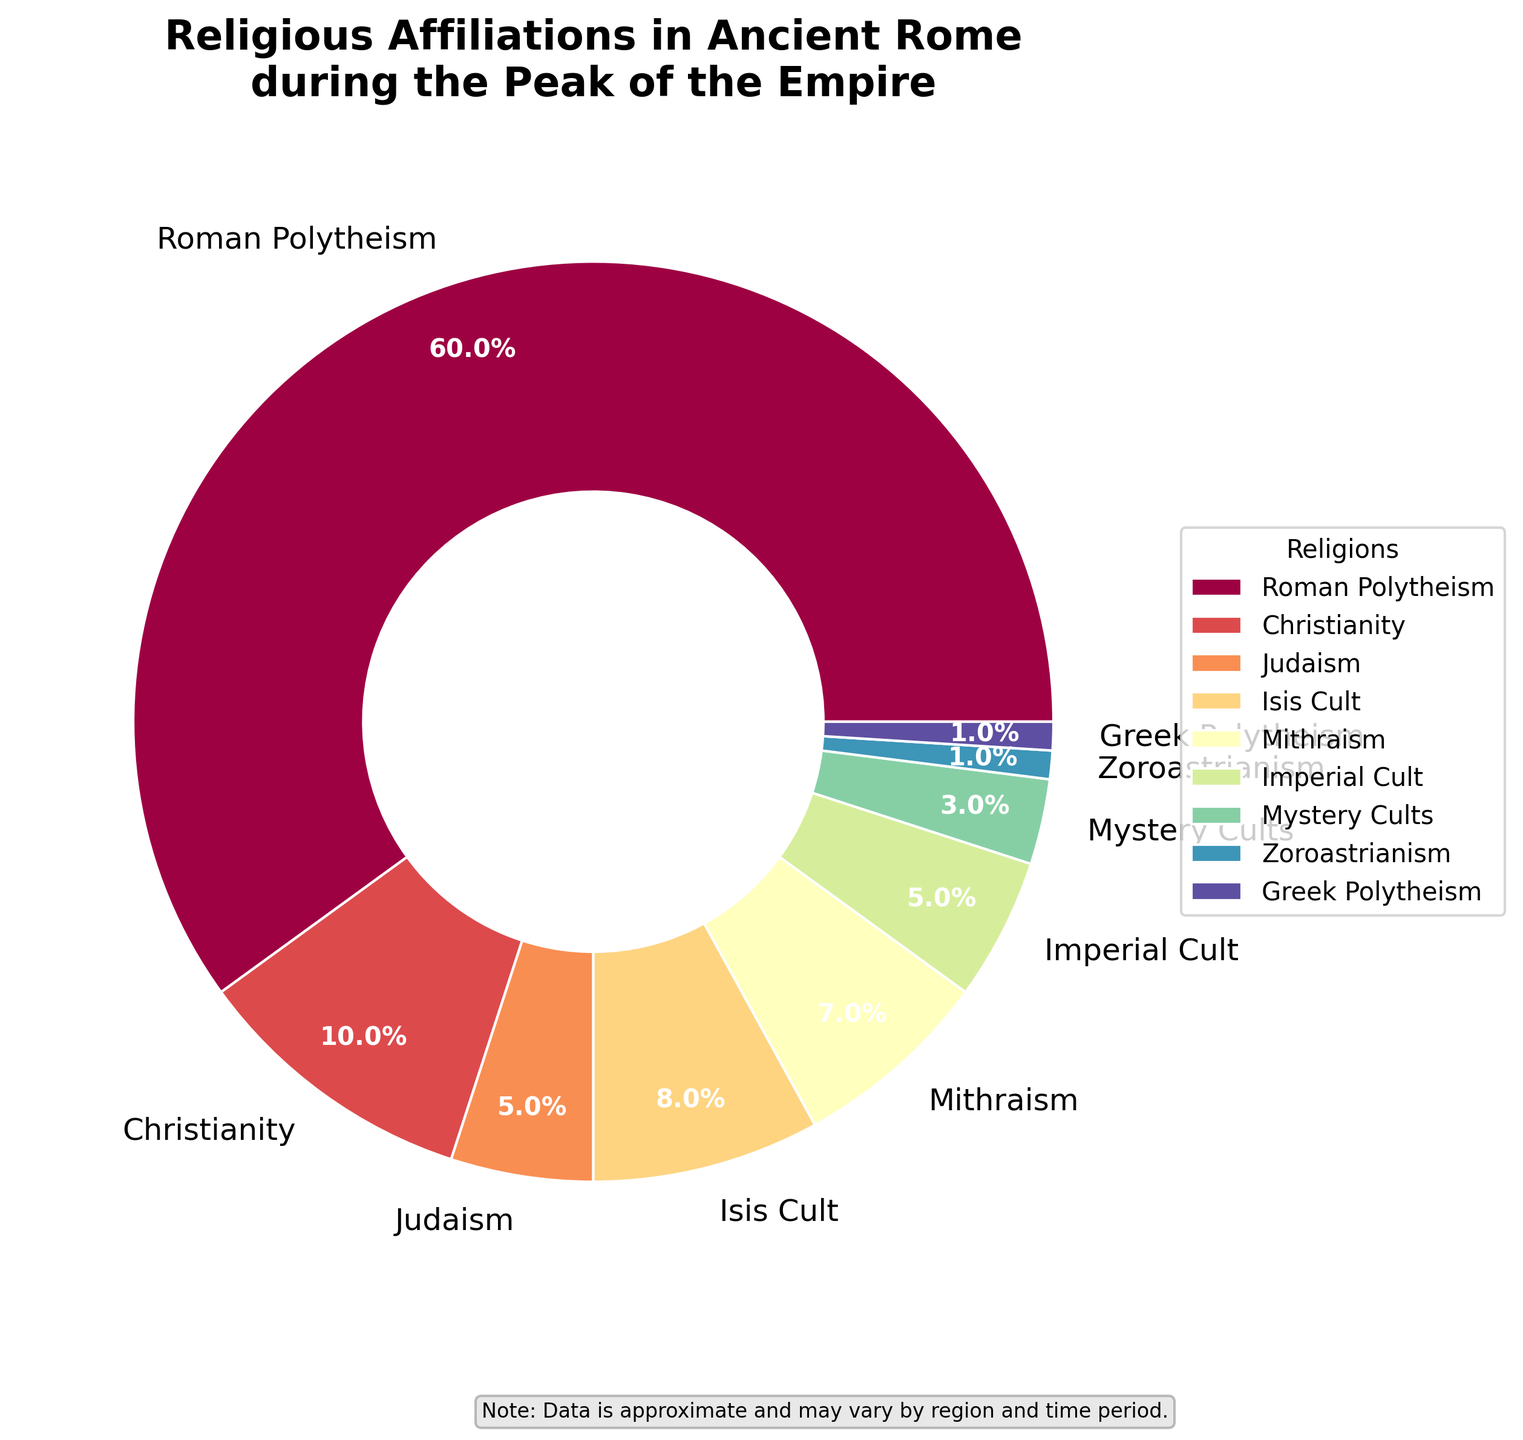Which religion has the highest percentage in Ancient Rome during the peak of the Empire? Look at the pie chart and identify the religion with the largest section. The label for Roman Polytheism indicates it has the highest percentage at 60%.
Answer: Roman Polytheism Which two religions have equal percentages and what are their percentages? Compare the labels on the pie chart to identify any religions with the same percentage. Imperial Cult and Judaism both have a percentage of 5%.
Answer: Imperial Cult and Judaism, 5% What is the combined percentage of Christianity and Isis Cult? Add the percentages of Christianity (10%) and Isis Cult (8%). The sum is 10% + 8% = 18%.
Answer: 18% Which cult has a higher percentage, Isis Cult or Mithraism, and by how much? Compare the percentages by subtracting Mithraism (7%) from Isis Cult (8%). The difference is 8% - 7% = 1%.
Answer: Isis Cult by 1% What is the total percentage of religions categorized as cults (Isis Cult, Mithraism, Imperial Cult, Mystery Cults)? Add the percentages for all the cults: Isis Cult (8%), Mithraism (7%), Imperial Cult (5%), and Mystery Cults (3%). The sum is 8% + 7% + 5% + 3% = 23%.
Answer: 23% Is Roman Polytheism's percentage greater than the combined percentage of all cults and Christianity? Add the percentages of all cults (23%) and Christianity (10%). The total is 23% + 10% = 33%. Compare it with Roman Polytheism's percentage (60%). Since 60% > 33%, Roman Polytheism is greater.
Answer: Yes Which religions account for exactly 1% each? Identify the religions marked with 1% on the pie chart. Zoroastrianism and Greek Polytheism each account for 1%.
Answer: Zoroastrianism and Greek Polytheism What is the difference in percentage between Roman Polytheism and all other religions combined? Subtract the percentage of Roman Polytheism (60%) from 100% to find the combined percentage of all other religions. The result is 100% - 60% = 40%.
Answer: 40% Which religion is represented by the smallest section on the pie chart, and what is its percentage? Identify the smallest section in the pie chart, which is labeled with its percentage. The smallest section is Zoroastrianism with 1%.
Answer: Zoroastrianism, 1% What is the average percentage of all the religions except Roman Polytheism? Add the percentages of all religions except Roman Polytheism and divide by the number of these religions. [(10%+5%+8%+7%+5%+3%+1%+1%)/8]= 40%/8 = 5%.
Answer: 5% 